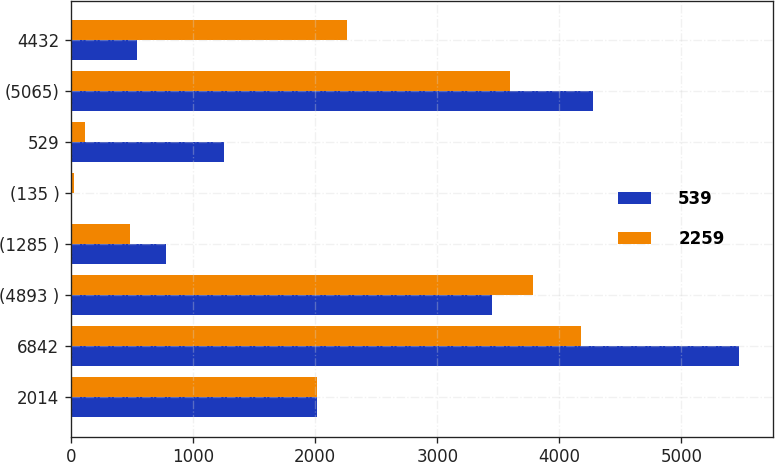<chart> <loc_0><loc_0><loc_500><loc_500><stacked_bar_chart><ecel><fcel>2014<fcel>6842<fcel>(4893 )<fcel>(1285 )<fcel>(135 )<fcel>529<fcel>(5065)<fcel>4432<nl><fcel>539<fcel>2013<fcel>5475<fcel>3444<fcel>775<fcel>5<fcel>1251<fcel>4276<fcel>539<nl><fcel>2259<fcel>2012<fcel>4180<fcel>3785<fcel>486<fcel>20<fcel>111<fcel>3595<fcel>2259<nl></chart> 